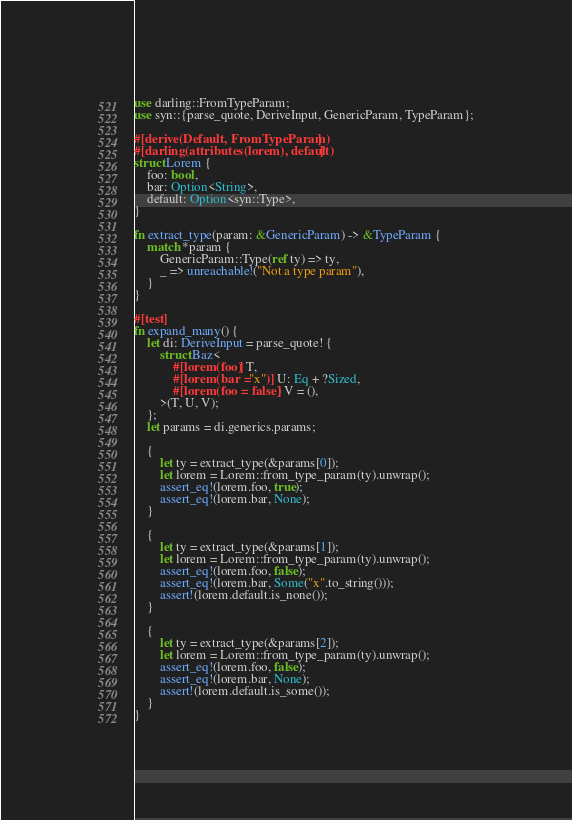<code> <loc_0><loc_0><loc_500><loc_500><_Rust_>use darling::FromTypeParam;
use syn::{parse_quote, DeriveInput, GenericParam, TypeParam};

#[derive(Default, FromTypeParam)]
#[darling(attributes(lorem), default)]
struct Lorem {
    foo: bool,
    bar: Option<String>,
    default: Option<syn::Type>,
}

fn extract_type(param: &GenericParam) -> &TypeParam {
    match *param {
        GenericParam::Type(ref ty) => ty,
        _ => unreachable!("Not a type param"),
    }
}

#[test]
fn expand_many() {
    let di: DeriveInput = parse_quote! {
        struct Baz<
            #[lorem(foo)] T,
            #[lorem(bar = "x")] U: Eq + ?Sized,
            #[lorem(foo = false)] V = (),
        >(T, U, V);
    };
    let params = di.generics.params;

    {
        let ty = extract_type(&params[0]);
        let lorem = Lorem::from_type_param(ty).unwrap();
        assert_eq!(lorem.foo, true);
        assert_eq!(lorem.bar, None);
    }

    {
        let ty = extract_type(&params[1]);
        let lorem = Lorem::from_type_param(ty).unwrap();
        assert_eq!(lorem.foo, false);
        assert_eq!(lorem.bar, Some("x".to_string()));
        assert!(lorem.default.is_none());
    }

    {
        let ty = extract_type(&params[2]);
        let lorem = Lorem::from_type_param(ty).unwrap();
        assert_eq!(lorem.foo, false);
        assert_eq!(lorem.bar, None);
        assert!(lorem.default.is_some());
    }
}
</code> 